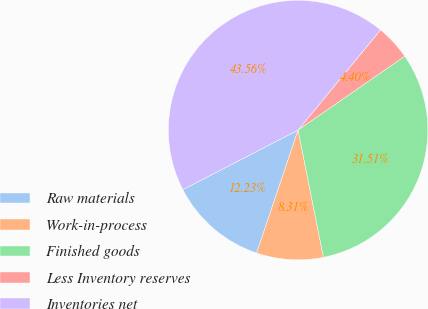Convert chart. <chart><loc_0><loc_0><loc_500><loc_500><pie_chart><fcel>Raw materials<fcel>Work-in-process<fcel>Finished goods<fcel>Less Inventory reserves<fcel>Inventories net<nl><fcel>12.23%<fcel>8.31%<fcel>31.51%<fcel>4.4%<fcel>43.56%<nl></chart> 